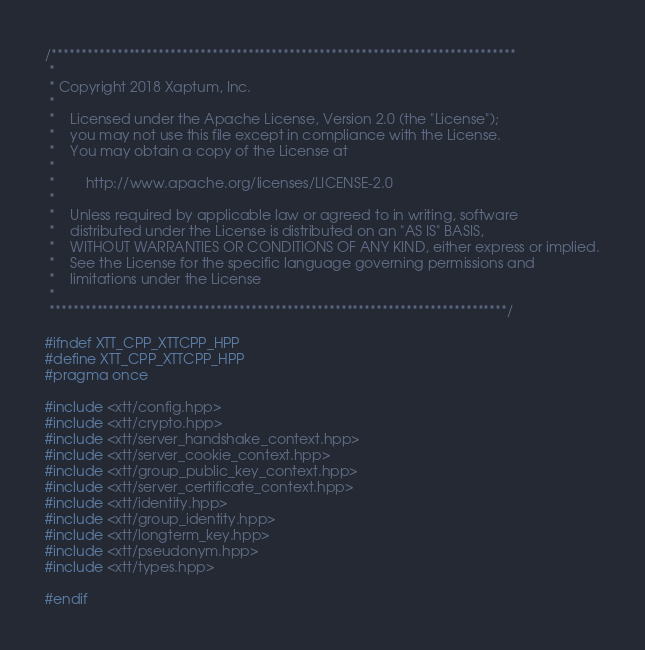Convert code to text. <code><loc_0><loc_0><loc_500><loc_500><_C++_>/******************************************************************************
 *
 * Copyright 2018 Xaptum, Inc.
 *
 *    Licensed under the Apache License, Version 2.0 (the "License");
 *    you may not use this file except in compliance with the License.
 *    You may obtain a copy of the License at
 *
 *        http://www.apache.org/licenses/LICENSE-2.0
 *
 *    Unless required by applicable law or agreed to in writing, software
 *    distributed under the License is distributed on an "AS IS" BASIS,
 *    WITHOUT WARRANTIES OR CONDITIONS OF ANY KIND, either express or implied.
 *    See the License for the specific language governing permissions and
 *    limitations under the License
 *
 *****************************************************************************/

#ifndef XTT_CPP_XTTCPP_HPP
#define XTT_CPP_XTTCPP_HPP
#pragma once

#include <xtt/config.hpp>
#include <xtt/crypto.hpp>
#include <xtt/server_handshake_context.hpp>
#include <xtt/server_cookie_context.hpp>
#include <xtt/group_public_key_context.hpp>
#include <xtt/server_certificate_context.hpp>
#include <xtt/identity.hpp>
#include <xtt/group_identity.hpp>
#include <xtt/longterm_key.hpp>
#include <xtt/pseudonym.hpp>
#include <xtt/types.hpp>

#endif
</code> 